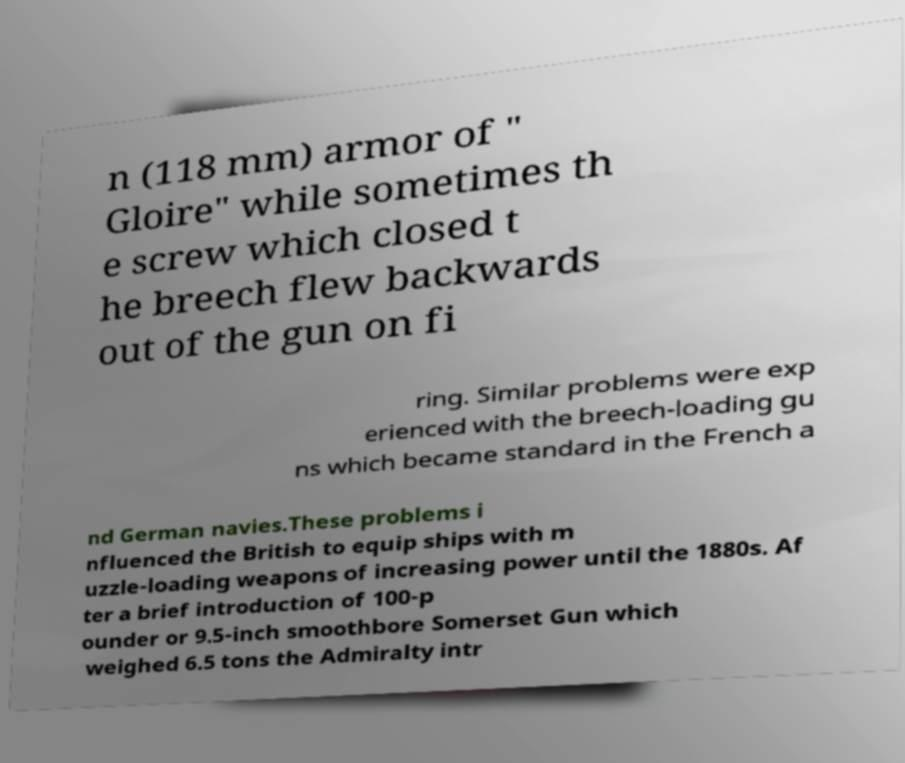Can you read and provide the text displayed in the image?This photo seems to have some interesting text. Can you extract and type it out for me? n (118 mm) armor of " Gloire" while sometimes th e screw which closed t he breech flew backwards out of the gun on fi ring. Similar problems were exp erienced with the breech-loading gu ns which became standard in the French a nd German navies.These problems i nfluenced the British to equip ships with m uzzle-loading weapons of increasing power until the 1880s. Af ter a brief introduction of 100-p ounder or 9.5-inch smoothbore Somerset Gun which weighed 6.5 tons the Admiralty intr 